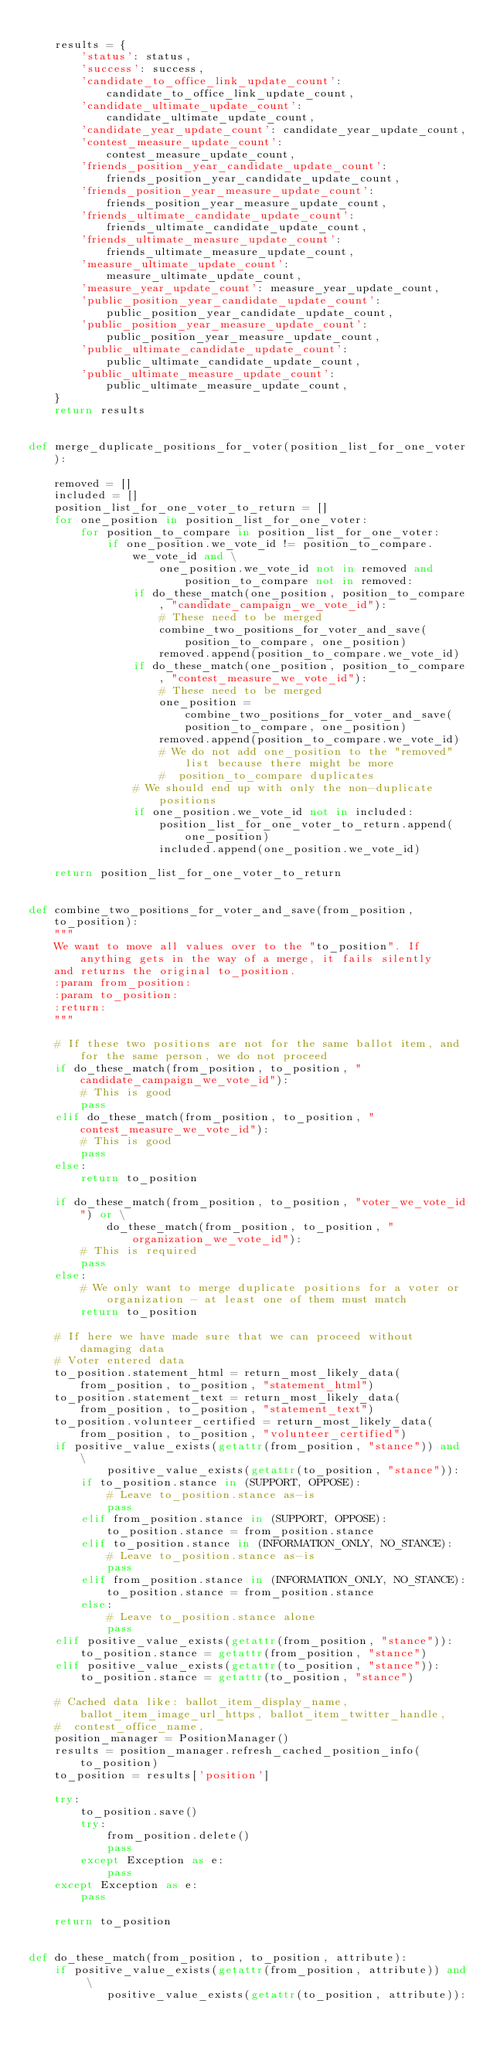<code> <loc_0><loc_0><loc_500><loc_500><_Python_>
    results = {
        'status': status,
        'success': success,
        'candidate_to_office_link_update_count': candidate_to_office_link_update_count,
        'candidate_ultimate_update_count': candidate_ultimate_update_count,
        'candidate_year_update_count': candidate_year_update_count,
        'contest_measure_update_count': contest_measure_update_count,
        'friends_position_year_candidate_update_count': friends_position_year_candidate_update_count,
        'friends_position_year_measure_update_count': friends_position_year_measure_update_count,
        'friends_ultimate_candidate_update_count': friends_ultimate_candidate_update_count,
        'friends_ultimate_measure_update_count': friends_ultimate_measure_update_count,
        'measure_ultimate_update_count': measure_ultimate_update_count,
        'measure_year_update_count': measure_year_update_count,
        'public_position_year_candidate_update_count': public_position_year_candidate_update_count,
        'public_position_year_measure_update_count': public_position_year_measure_update_count,
        'public_ultimate_candidate_update_count': public_ultimate_candidate_update_count,
        'public_ultimate_measure_update_count': public_ultimate_measure_update_count,
    }
    return results


def merge_duplicate_positions_for_voter(position_list_for_one_voter):

    removed = []
    included = []
    position_list_for_one_voter_to_return = []
    for one_position in position_list_for_one_voter:
        for position_to_compare in position_list_for_one_voter:
            if one_position.we_vote_id != position_to_compare.we_vote_id and \
                    one_position.we_vote_id not in removed and position_to_compare not in removed:
                if do_these_match(one_position, position_to_compare, "candidate_campaign_we_vote_id"):
                    # These need to be merged
                    combine_two_positions_for_voter_and_save(position_to_compare, one_position)
                    removed.append(position_to_compare.we_vote_id)
                if do_these_match(one_position, position_to_compare, "contest_measure_we_vote_id"):
                    # These need to be merged
                    one_position = combine_two_positions_for_voter_and_save(position_to_compare, one_position)
                    removed.append(position_to_compare.we_vote_id)
                    # We do not add one_position to the "removed" list because there might be more
                    #  position_to_compare duplicates
                # We should end up with only the non-duplicate positions
                if one_position.we_vote_id not in included:
                    position_list_for_one_voter_to_return.append(one_position)
                    included.append(one_position.we_vote_id)

    return position_list_for_one_voter_to_return


def combine_two_positions_for_voter_and_save(from_position, to_position):
    """
    We want to move all values over to the "to_position". If anything gets in the way of a merge, it fails silently
    and returns the original to_position.
    :param from_position:
    :param to_position:
    :return:
    """

    # If these two positions are not for the same ballot item, and for the same person, we do not proceed
    if do_these_match(from_position, to_position, "candidate_campaign_we_vote_id"):
        # This is good
        pass
    elif do_these_match(from_position, to_position, "contest_measure_we_vote_id"):
        # This is good
        pass
    else:
        return to_position

    if do_these_match(from_position, to_position, "voter_we_vote_id") or \
            do_these_match(from_position, to_position, "organization_we_vote_id"):
        # This is required
        pass
    else:
        # We only want to merge duplicate positions for a voter or organization - at least one of them must match
        return to_position

    # If here we have made sure that we can proceed without damaging data
    # Voter entered data
    to_position.statement_html = return_most_likely_data(from_position, to_position, "statement_html")
    to_position.statement_text = return_most_likely_data(from_position, to_position, "statement_text")
    to_position.volunteer_certified = return_most_likely_data(from_position, to_position, "volunteer_certified")
    if positive_value_exists(getattr(from_position, "stance")) and \
            positive_value_exists(getattr(to_position, "stance")):
        if to_position.stance in (SUPPORT, OPPOSE):
            # Leave to_position.stance as-is
            pass
        elif from_position.stance in (SUPPORT, OPPOSE):
            to_position.stance = from_position.stance
        elif to_position.stance in (INFORMATION_ONLY, NO_STANCE):
            # Leave to_position.stance as-is
            pass
        elif from_position.stance in (INFORMATION_ONLY, NO_STANCE):
            to_position.stance = from_position.stance
        else:
            # Leave to_position.stance alone
            pass
    elif positive_value_exists(getattr(from_position, "stance")):
        to_position.stance = getattr(from_position, "stance")
    elif positive_value_exists(getattr(to_position, "stance")):
        to_position.stance = getattr(to_position, "stance")

    # Cached data like: ballot_item_display_name, ballot_item_image_url_https, ballot_item_twitter_handle,
    #  contest_office_name,
    position_manager = PositionManager()
    results = position_manager.refresh_cached_position_info(to_position)
    to_position = results['position']

    try:
        to_position.save()
        try:
            from_position.delete()
            pass
        except Exception as e:
            pass
    except Exception as e:
        pass

    return to_position


def do_these_match(from_position, to_position, attribute):
    if positive_value_exists(getattr(from_position, attribute)) and \
            positive_value_exists(getattr(to_position, attribute)):</code> 